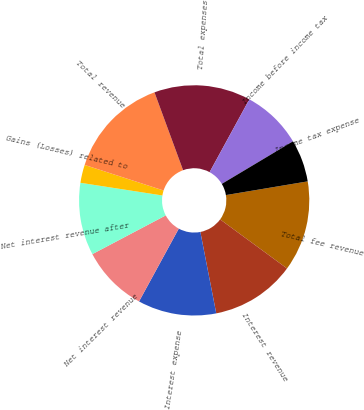Convert chart to OTSL. <chart><loc_0><loc_0><loc_500><loc_500><pie_chart><fcel>Total fee revenue<fcel>Interest revenue<fcel>Interest expense<fcel>Net interest revenue<fcel>Net interest revenue after<fcel>Gains (Losses) related to<fcel>Total revenue<fcel>Total expenses<fcel>Income before income tax<fcel>Income tax expense<nl><fcel>12.71%<fcel>11.86%<fcel>11.02%<fcel>9.32%<fcel>10.17%<fcel>2.54%<fcel>14.41%<fcel>13.56%<fcel>8.47%<fcel>5.93%<nl></chart> 